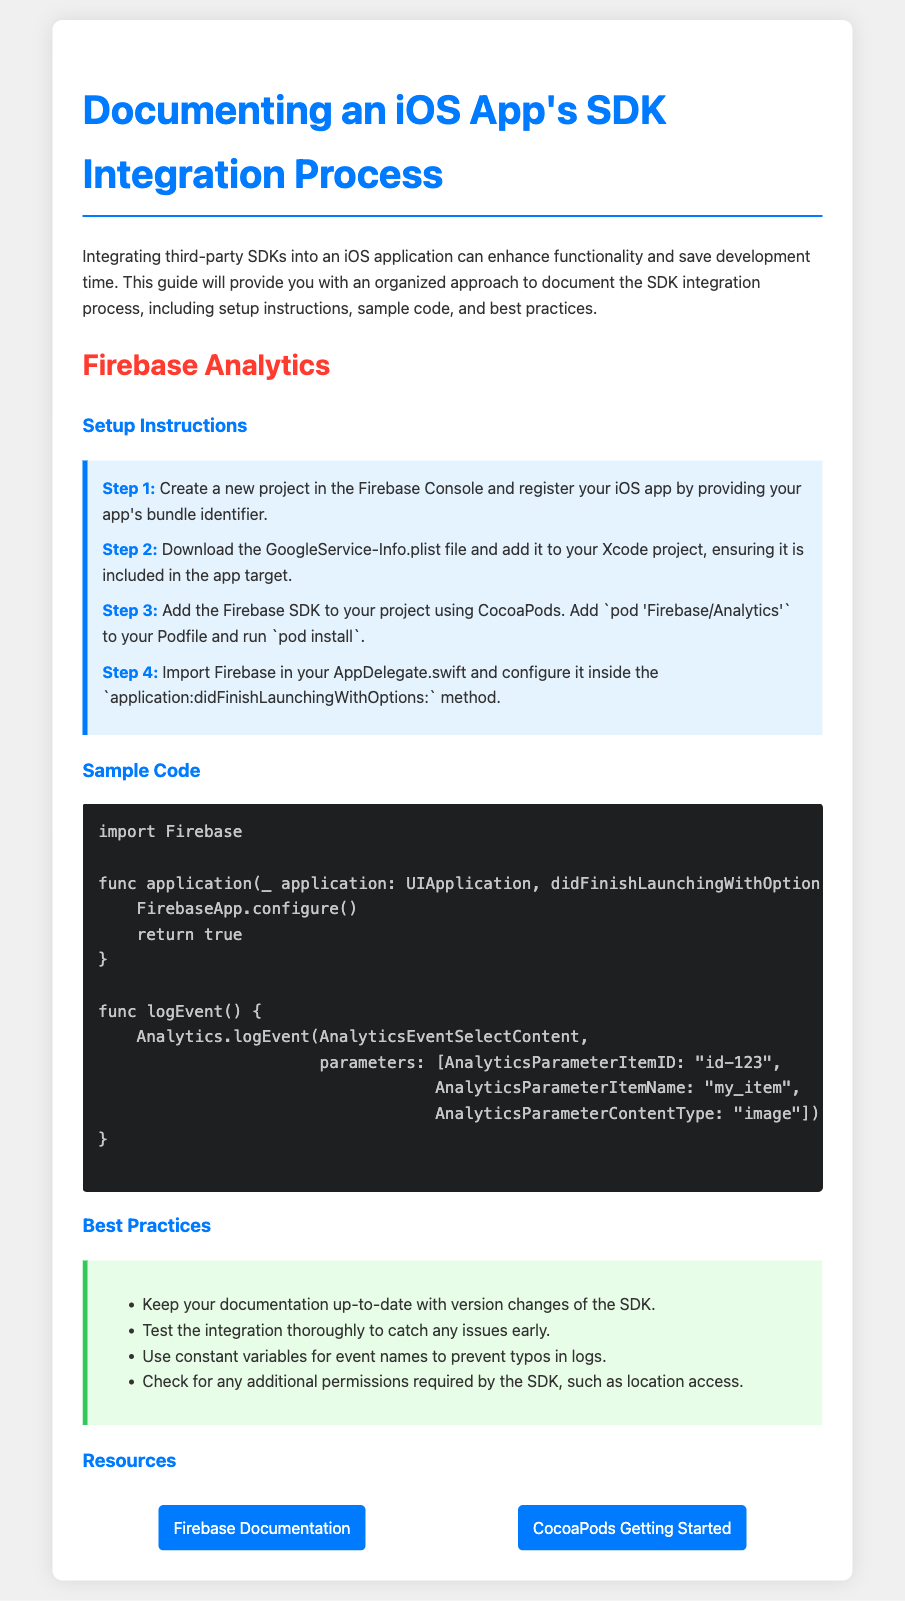What is the name of the SDK documented? The document provides setup instructions for integrating Firebase Analytics into an iOS app.
Answer: Firebase Analytics How many steps are in the setup instructions? The document outlines a total of four distinct steps for setting up the SDK integration.
Answer: 4 What is the first step in the setup instructions? The first step involves creating a new project in the Firebase Console and registering your iOS app.
Answer: Create a new project in the Firebase Console What code do you need to add to the Podfile? The specific line to include in the Podfile for adding the Firebase SDK is noted in the setup instructions.
Answer: pod 'Firebase/Analytics' Which method is used to configure Firebase in the AppDelegate? The setup instructions specify where to import and configure Firebase within the AppDelegate.
Answer: application:didFinishLaunchingWithOptions: What is one best practice for documenting the SDK integration process? The document highlights various best practices to ensure proper integration; one is to keep documentation updated.
Answer: Keep your documentation up-to-date How can you log an event in the sample code? The sample code demonstrates how to log an event using a specific method from the Firebase SDK.
Answer: Analytics.logEvent What is the background color of the best practices section? The document uses specific colors to differentiate sections; the best practices section has a light green background.
Answer: Light green What resource link is provided for Firebase documentation? The document contains a URL that directs users to the official documentation for Firebase.
Answer: https://firebase.google.com/docs/analytics 